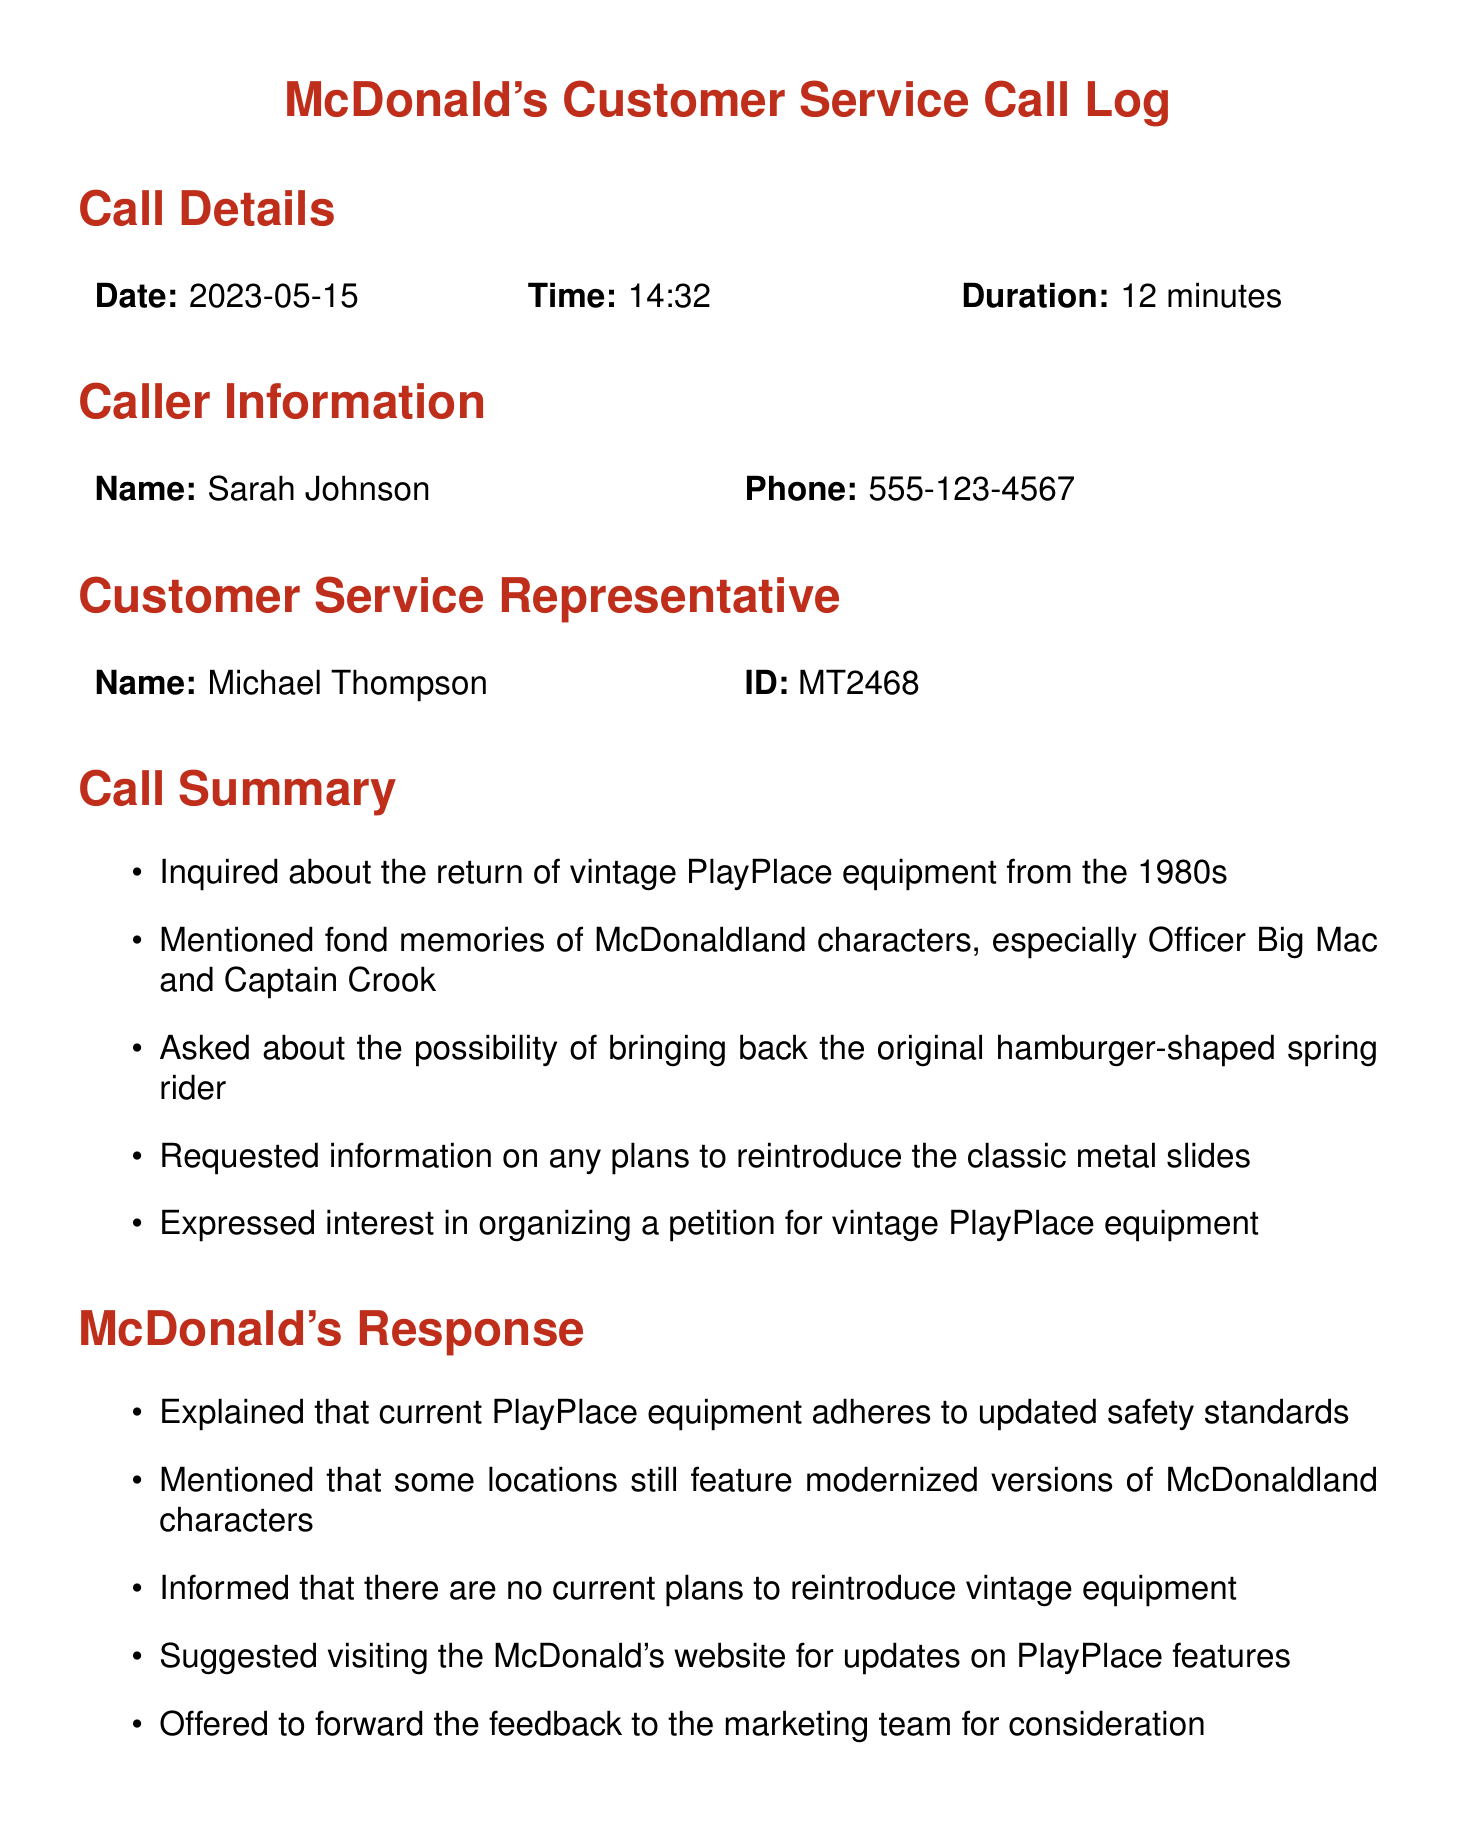What is the date of the call? The date of the call is specified in the Call Details section.
Answer: 2023-05-15 What was the duration of the call? The duration of the call is included in the Call Details section.
Answer: 12 minutes Who was the customer service representative? The name of the customer service representative is listed in the Caller Information section.
Answer: Michael Thompson What did the caller express interest in organizing? This information is found in the Call Summary section, reflecting the caller's interests.
Answer: A petition What was mentioned about the current PlayPlace equipment? This detail is provided under McDonald's Response regarding safety standards.
Answer: Updated safety standards How did the representative suggest for the caller to stay informed? The suggestion is included in the Follow-up Actions section.
Answer: Mailing list On what date and time did the call occur? Both the date and time are found in the Call Details section.
Answer: 2023-05-15, 14:32 Is there a plan to reintroduce vintage equipment? This information is addressed in the McDonald's Response section.
Answer: No What nostalgic characters did the caller mention? The Call Summary section lists characters mentioned by the caller.
Answer: Officer Big Mac, Captain Crook 